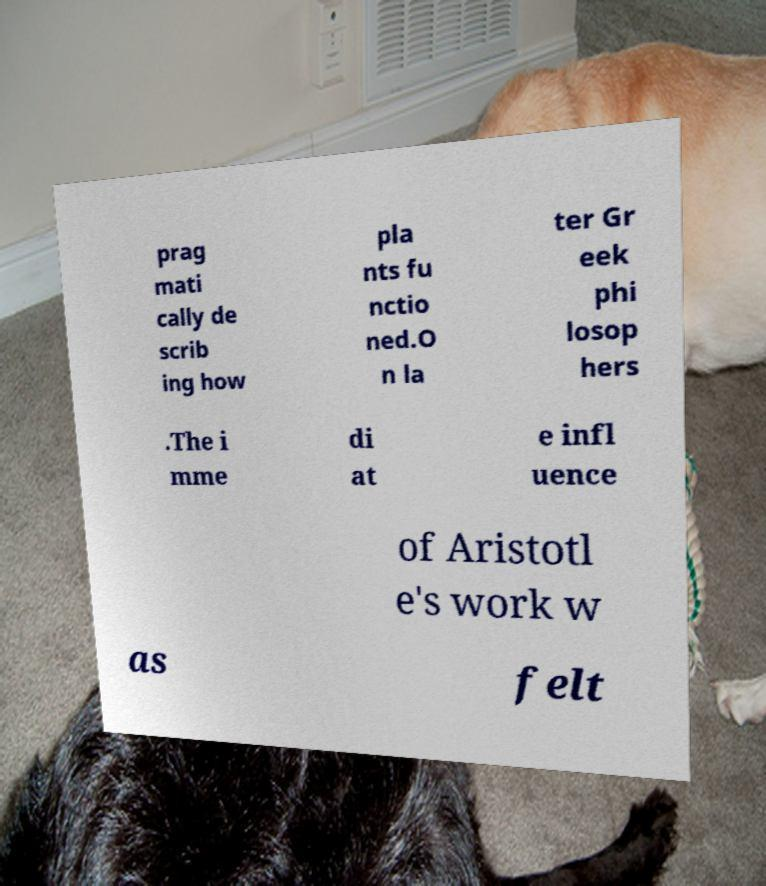Could you extract and type out the text from this image? prag mati cally de scrib ing how pla nts fu nctio ned.O n la ter Gr eek phi losop hers .The i mme di at e infl uence of Aristotl e's work w as felt 